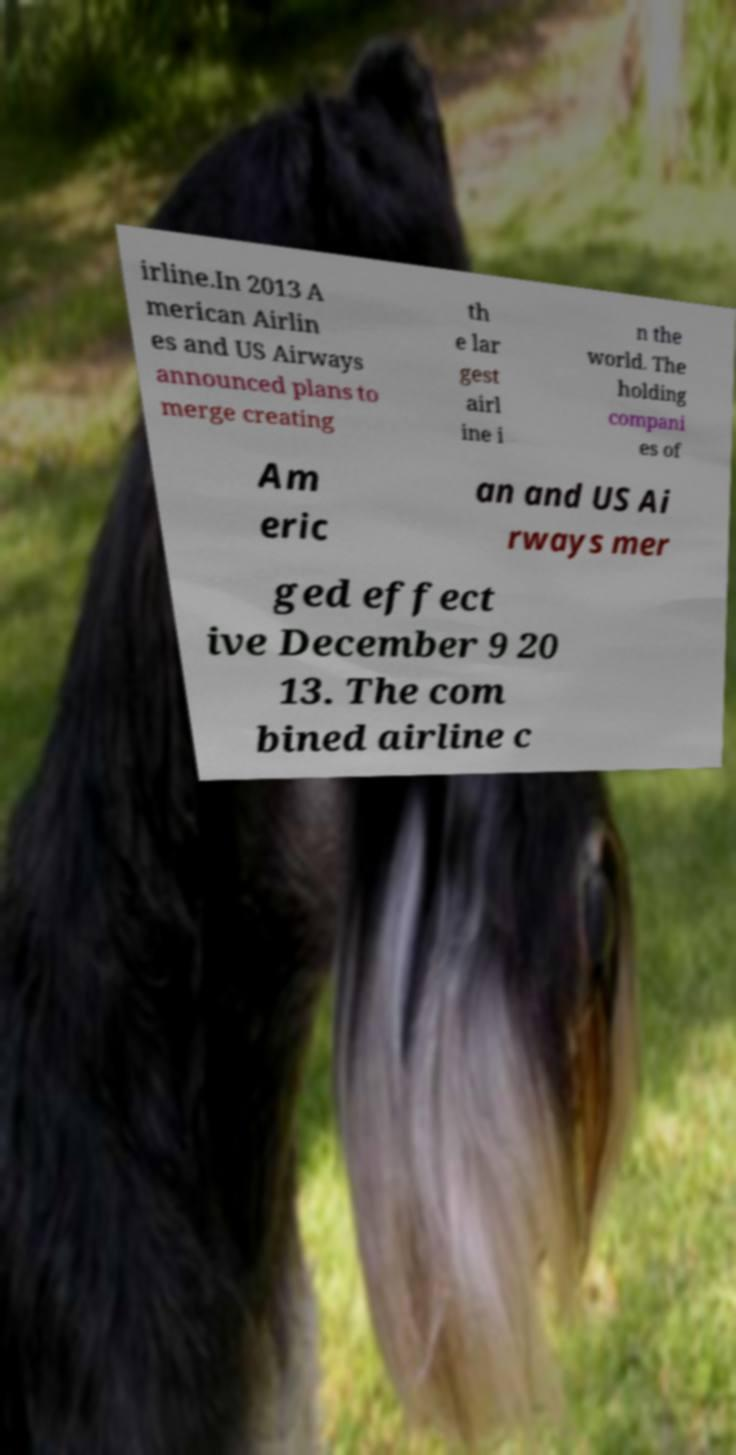What messages or text are displayed in this image? I need them in a readable, typed format. irline.In 2013 A merican Airlin es and US Airways announced plans to merge creating th e lar gest airl ine i n the world. The holding compani es of Am eric an and US Ai rways mer ged effect ive December 9 20 13. The com bined airline c 